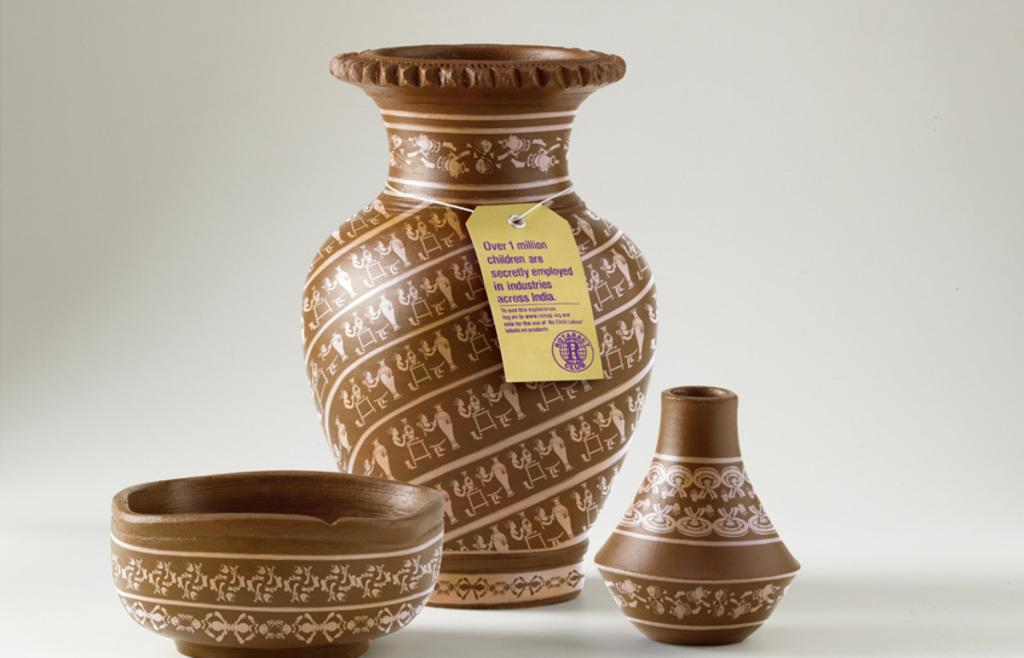What type of objects are present in the image? There are ceramic objects in the image. Can you describe any specific features of these objects? One of the ceramic objects has a tag on it. What information can be found on the tag? There is text on the tag. Is there a slope visible in the image? No, there is no slope present in the image. Can you find a receipt for the ceramic objects in the image? There is no receipt visible in the image. 